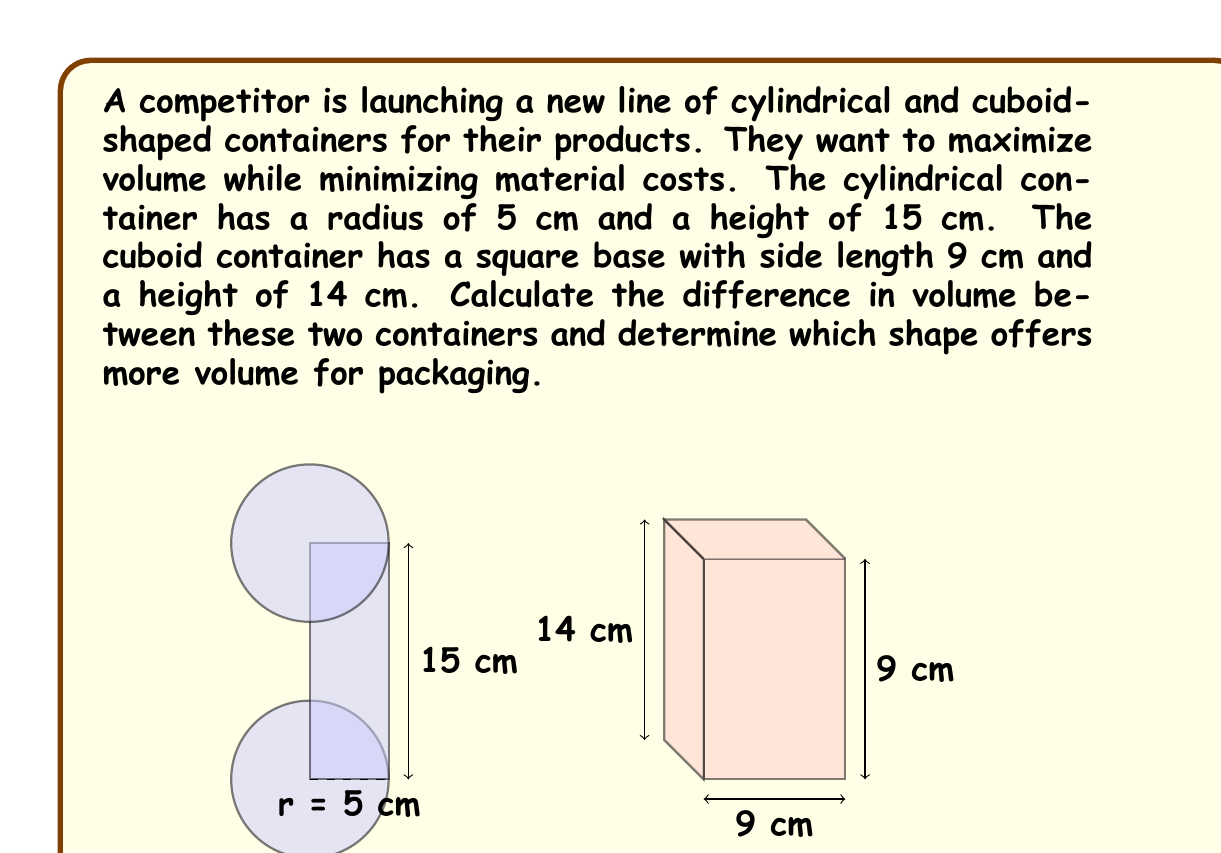Can you solve this math problem? To solve this problem, we need to calculate the volumes of both containers and then find their difference.

1. Volume of the cylindrical container:
   The formula for the volume of a cylinder is $V = \pi r^2 h$, where $r$ is the radius and $h$ is the height.
   
   $$V_{cylinder} = \pi \cdot 5^2 \cdot 15 = 375\pi \approx 1178.10 \text{ cm}^3$$

2. Volume of the cuboid container:
   The formula for the volume of a cuboid is $V = l \cdot w \cdot h$, where $l$ is length, $w$ is width, and $h$ is height.
   
   $$V_{cuboid} = 9 \cdot 9 \cdot 14 = 1134 \text{ cm}^3$$

3. Difference in volume:
   $$\text{Difference} = V_{cylinder} - V_{cuboid} = 1178.10 - 1134 = 44.10 \text{ cm}^3$$

The cylindrical container offers more volume for packaging, with a difference of approximately 44.10 cm³.

This result shows that the cylindrical shape provides a slightly larger volume while potentially using less material for its surface area, which could be more cost-effective for packaging.
Answer: The difference in volume is approximately 44.10 cm³, with the cylindrical container offering more volume for packaging. 